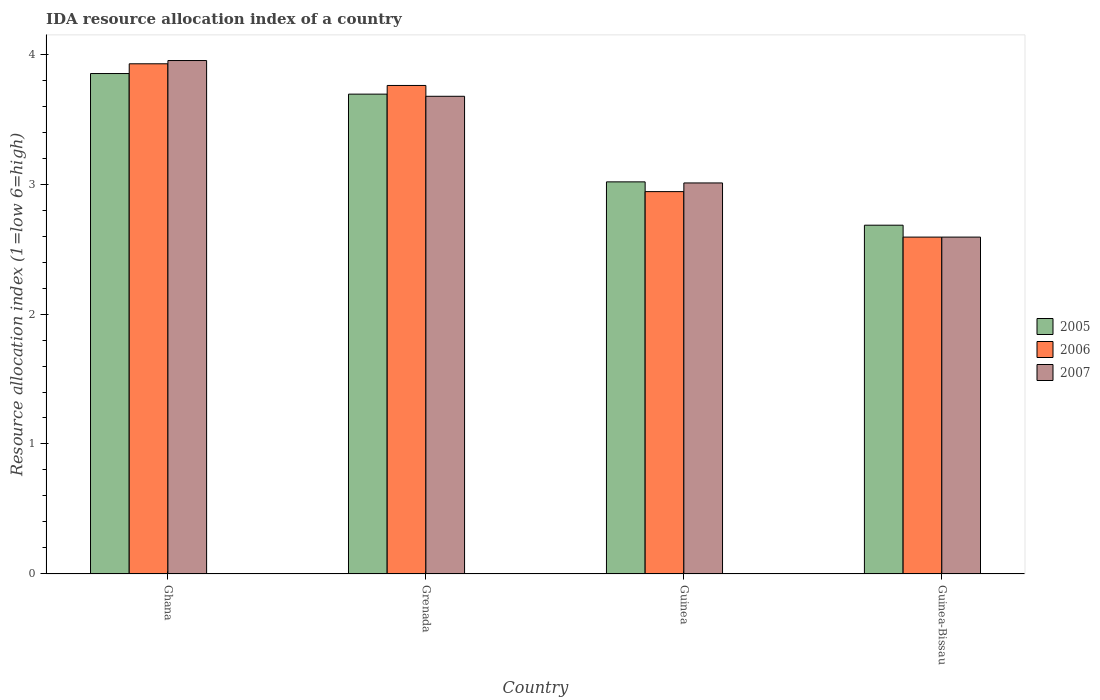How many different coloured bars are there?
Make the answer very short. 3. How many groups of bars are there?
Your response must be concise. 4. How many bars are there on the 2nd tick from the left?
Ensure brevity in your answer.  3. What is the label of the 4th group of bars from the left?
Ensure brevity in your answer.  Guinea-Bissau. In how many cases, is the number of bars for a given country not equal to the number of legend labels?
Your answer should be compact. 0. What is the IDA resource allocation index in 2005 in Guinea?
Your answer should be very brief. 3.02. Across all countries, what is the maximum IDA resource allocation index in 2007?
Your answer should be very brief. 3.95. Across all countries, what is the minimum IDA resource allocation index in 2006?
Offer a terse response. 2.59. In which country was the IDA resource allocation index in 2007 maximum?
Your answer should be compact. Ghana. In which country was the IDA resource allocation index in 2005 minimum?
Give a very brief answer. Guinea-Bissau. What is the total IDA resource allocation index in 2005 in the graph?
Make the answer very short. 13.24. What is the difference between the IDA resource allocation index in 2007 in Ghana and that in Guinea-Bissau?
Your answer should be very brief. 1.36. What is the difference between the IDA resource allocation index in 2005 in Guinea-Bissau and the IDA resource allocation index in 2006 in Guinea?
Ensure brevity in your answer.  -0.26. What is the average IDA resource allocation index in 2006 per country?
Ensure brevity in your answer.  3.3. What is the difference between the IDA resource allocation index of/in 2006 and IDA resource allocation index of/in 2005 in Grenada?
Your response must be concise. 0.07. In how many countries, is the IDA resource allocation index in 2007 greater than 2.2?
Offer a very short reply. 4. What is the ratio of the IDA resource allocation index in 2007 in Ghana to that in Grenada?
Your response must be concise. 1.07. Is the difference between the IDA resource allocation index in 2006 in Guinea and Guinea-Bissau greater than the difference between the IDA resource allocation index in 2005 in Guinea and Guinea-Bissau?
Your response must be concise. Yes. What is the difference between the highest and the second highest IDA resource allocation index in 2005?
Make the answer very short. 0.67. What is the difference between the highest and the lowest IDA resource allocation index in 2007?
Your answer should be compact. 1.36. In how many countries, is the IDA resource allocation index in 2006 greater than the average IDA resource allocation index in 2006 taken over all countries?
Your answer should be very brief. 2. What does the 3rd bar from the left in Grenada represents?
Ensure brevity in your answer.  2007. What does the 3rd bar from the right in Ghana represents?
Your answer should be very brief. 2005. Are all the bars in the graph horizontal?
Your answer should be very brief. No. How many countries are there in the graph?
Offer a terse response. 4. Does the graph contain any zero values?
Your response must be concise. No. Does the graph contain grids?
Provide a succinct answer. No. How many legend labels are there?
Provide a short and direct response. 3. What is the title of the graph?
Your answer should be compact. IDA resource allocation index of a country. Does "1970" appear as one of the legend labels in the graph?
Your response must be concise. No. What is the label or title of the X-axis?
Provide a short and direct response. Country. What is the label or title of the Y-axis?
Provide a short and direct response. Resource allocation index (1=low 6=high). What is the Resource allocation index (1=low 6=high) of 2005 in Ghana?
Make the answer very short. 3.85. What is the Resource allocation index (1=low 6=high) in 2006 in Ghana?
Provide a succinct answer. 3.92. What is the Resource allocation index (1=low 6=high) in 2007 in Ghana?
Keep it short and to the point. 3.95. What is the Resource allocation index (1=low 6=high) in 2005 in Grenada?
Your response must be concise. 3.69. What is the Resource allocation index (1=low 6=high) of 2006 in Grenada?
Make the answer very short. 3.76. What is the Resource allocation index (1=low 6=high) of 2007 in Grenada?
Keep it short and to the point. 3.67. What is the Resource allocation index (1=low 6=high) in 2005 in Guinea?
Keep it short and to the point. 3.02. What is the Resource allocation index (1=low 6=high) of 2006 in Guinea?
Offer a terse response. 2.94. What is the Resource allocation index (1=low 6=high) in 2007 in Guinea?
Offer a terse response. 3.01. What is the Resource allocation index (1=low 6=high) of 2005 in Guinea-Bissau?
Offer a very short reply. 2.68. What is the Resource allocation index (1=low 6=high) in 2006 in Guinea-Bissau?
Offer a terse response. 2.59. What is the Resource allocation index (1=low 6=high) of 2007 in Guinea-Bissau?
Your response must be concise. 2.59. Across all countries, what is the maximum Resource allocation index (1=low 6=high) in 2005?
Keep it short and to the point. 3.85. Across all countries, what is the maximum Resource allocation index (1=low 6=high) of 2006?
Your response must be concise. 3.92. Across all countries, what is the maximum Resource allocation index (1=low 6=high) of 2007?
Your answer should be compact. 3.95. Across all countries, what is the minimum Resource allocation index (1=low 6=high) in 2005?
Provide a succinct answer. 2.68. Across all countries, what is the minimum Resource allocation index (1=low 6=high) of 2006?
Offer a terse response. 2.59. Across all countries, what is the minimum Resource allocation index (1=low 6=high) in 2007?
Your answer should be compact. 2.59. What is the total Resource allocation index (1=low 6=high) of 2005 in the graph?
Make the answer very short. 13.24. What is the total Resource allocation index (1=low 6=high) of 2006 in the graph?
Make the answer very short. 13.22. What is the total Resource allocation index (1=low 6=high) in 2007 in the graph?
Offer a very short reply. 13.22. What is the difference between the Resource allocation index (1=low 6=high) of 2005 in Ghana and that in Grenada?
Provide a succinct answer. 0.16. What is the difference between the Resource allocation index (1=low 6=high) in 2006 in Ghana and that in Grenada?
Provide a succinct answer. 0.17. What is the difference between the Resource allocation index (1=low 6=high) in 2007 in Ghana and that in Grenada?
Your answer should be compact. 0.28. What is the difference between the Resource allocation index (1=low 6=high) in 2005 in Ghana and that in Guinea?
Your answer should be very brief. 0.83. What is the difference between the Resource allocation index (1=low 6=high) in 2006 in Ghana and that in Guinea?
Keep it short and to the point. 0.98. What is the difference between the Resource allocation index (1=low 6=high) of 2007 in Ghana and that in Guinea?
Your answer should be very brief. 0.94. What is the difference between the Resource allocation index (1=low 6=high) in 2007 in Ghana and that in Guinea-Bissau?
Give a very brief answer. 1.36. What is the difference between the Resource allocation index (1=low 6=high) in 2005 in Grenada and that in Guinea?
Your response must be concise. 0.68. What is the difference between the Resource allocation index (1=low 6=high) in 2006 in Grenada and that in Guinea?
Keep it short and to the point. 0.82. What is the difference between the Resource allocation index (1=low 6=high) in 2007 in Grenada and that in Guinea?
Your response must be concise. 0.67. What is the difference between the Resource allocation index (1=low 6=high) in 2005 in Grenada and that in Guinea-Bissau?
Give a very brief answer. 1.01. What is the difference between the Resource allocation index (1=low 6=high) in 2006 in Grenada and that in Guinea-Bissau?
Give a very brief answer. 1.17. What is the difference between the Resource allocation index (1=low 6=high) in 2007 in Guinea and that in Guinea-Bissau?
Make the answer very short. 0.42. What is the difference between the Resource allocation index (1=low 6=high) in 2005 in Ghana and the Resource allocation index (1=low 6=high) in 2006 in Grenada?
Ensure brevity in your answer.  0.09. What is the difference between the Resource allocation index (1=low 6=high) in 2005 in Ghana and the Resource allocation index (1=low 6=high) in 2007 in Grenada?
Provide a succinct answer. 0.17. What is the difference between the Resource allocation index (1=low 6=high) in 2005 in Ghana and the Resource allocation index (1=low 6=high) in 2006 in Guinea?
Offer a terse response. 0.91. What is the difference between the Resource allocation index (1=low 6=high) of 2005 in Ghana and the Resource allocation index (1=low 6=high) of 2007 in Guinea?
Provide a succinct answer. 0.84. What is the difference between the Resource allocation index (1=low 6=high) in 2005 in Ghana and the Resource allocation index (1=low 6=high) in 2006 in Guinea-Bissau?
Provide a short and direct response. 1.26. What is the difference between the Resource allocation index (1=low 6=high) of 2005 in Ghana and the Resource allocation index (1=low 6=high) of 2007 in Guinea-Bissau?
Your response must be concise. 1.26. What is the difference between the Resource allocation index (1=low 6=high) in 2005 in Grenada and the Resource allocation index (1=low 6=high) in 2006 in Guinea?
Provide a succinct answer. 0.75. What is the difference between the Resource allocation index (1=low 6=high) of 2005 in Grenada and the Resource allocation index (1=low 6=high) of 2007 in Guinea?
Offer a terse response. 0.68. What is the difference between the Resource allocation index (1=low 6=high) of 2006 in Grenada and the Resource allocation index (1=low 6=high) of 2007 in Guinea?
Your response must be concise. 0.75. What is the difference between the Resource allocation index (1=low 6=high) of 2005 in Grenada and the Resource allocation index (1=low 6=high) of 2006 in Guinea-Bissau?
Make the answer very short. 1.1. What is the difference between the Resource allocation index (1=low 6=high) in 2005 in Guinea and the Resource allocation index (1=low 6=high) in 2006 in Guinea-Bissau?
Keep it short and to the point. 0.42. What is the difference between the Resource allocation index (1=low 6=high) of 2005 in Guinea and the Resource allocation index (1=low 6=high) of 2007 in Guinea-Bissau?
Your answer should be very brief. 0.42. What is the average Resource allocation index (1=low 6=high) of 2005 per country?
Ensure brevity in your answer.  3.31. What is the average Resource allocation index (1=low 6=high) of 2006 per country?
Offer a terse response. 3.3. What is the average Resource allocation index (1=low 6=high) of 2007 per country?
Ensure brevity in your answer.  3.31. What is the difference between the Resource allocation index (1=low 6=high) of 2005 and Resource allocation index (1=low 6=high) of 2006 in Ghana?
Your answer should be compact. -0.07. What is the difference between the Resource allocation index (1=low 6=high) in 2006 and Resource allocation index (1=low 6=high) in 2007 in Ghana?
Offer a terse response. -0.03. What is the difference between the Resource allocation index (1=low 6=high) in 2005 and Resource allocation index (1=low 6=high) in 2006 in Grenada?
Offer a terse response. -0.07. What is the difference between the Resource allocation index (1=low 6=high) of 2005 and Resource allocation index (1=low 6=high) of 2007 in Grenada?
Offer a very short reply. 0.02. What is the difference between the Resource allocation index (1=low 6=high) in 2006 and Resource allocation index (1=low 6=high) in 2007 in Grenada?
Keep it short and to the point. 0.08. What is the difference between the Resource allocation index (1=low 6=high) in 2005 and Resource allocation index (1=low 6=high) in 2006 in Guinea?
Provide a short and direct response. 0.07. What is the difference between the Resource allocation index (1=low 6=high) of 2005 and Resource allocation index (1=low 6=high) of 2007 in Guinea?
Offer a terse response. 0.01. What is the difference between the Resource allocation index (1=low 6=high) in 2006 and Resource allocation index (1=low 6=high) in 2007 in Guinea?
Provide a succinct answer. -0.07. What is the difference between the Resource allocation index (1=low 6=high) of 2005 and Resource allocation index (1=low 6=high) of 2006 in Guinea-Bissau?
Your response must be concise. 0.09. What is the difference between the Resource allocation index (1=low 6=high) in 2005 and Resource allocation index (1=low 6=high) in 2007 in Guinea-Bissau?
Keep it short and to the point. 0.09. What is the difference between the Resource allocation index (1=low 6=high) in 2006 and Resource allocation index (1=low 6=high) in 2007 in Guinea-Bissau?
Provide a short and direct response. 0. What is the ratio of the Resource allocation index (1=low 6=high) of 2005 in Ghana to that in Grenada?
Make the answer very short. 1.04. What is the ratio of the Resource allocation index (1=low 6=high) of 2006 in Ghana to that in Grenada?
Your answer should be compact. 1.04. What is the ratio of the Resource allocation index (1=low 6=high) in 2007 in Ghana to that in Grenada?
Provide a succinct answer. 1.07. What is the ratio of the Resource allocation index (1=low 6=high) in 2005 in Ghana to that in Guinea?
Your answer should be very brief. 1.28. What is the ratio of the Resource allocation index (1=low 6=high) of 2006 in Ghana to that in Guinea?
Make the answer very short. 1.33. What is the ratio of the Resource allocation index (1=low 6=high) of 2007 in Ghana to that in Guinea?
Give a very brief answer. 1.31. What is the ratio of the Resource allocation index (1=low 6=high) in 2005 in Ghana to that in Guinea-Bissau?
Offer a very short reply. 1.43. What is the ratio of the Resource allocation index (1=low 6=high) in 2006 in Ghana to that in Guinea-Bissau?
Ensure brevity in your answer.  1.51. What is the ratio of the Resource allocation index (1=low 6=high) of 2007 in Ghana to that in Guinea-Bissau?
Your answer should be compact. 1.52. What is the ratio of the Resource allocation index (1=low 6=high) in 2005 in Grenada to that in Guinea?
Your answer should be compact. 1.22. What is the ratio of the Resource allocation index (1=low 6=high) in 2006 in Grenada to that in Guinea?
Give a very brief answer. 1.28. What is the ratio of the Resource allocation index (1=low 6=high) of 2007 in Grenada to that in Guinea?
Keep it short and to the point. 1.22. What is the ratio of the Resource allocation index (1=low 6=high) in 2005 in Grenada to that in Guinea-Bissau?
Offer a terse response. 1.38. What is the ratio of the Resource allocation index (1=low 6=high) in 2006 in Grenada to that in Guinea-Bissau?
Make the answer very short. 1.45. What is the ratio of the Resource allocation index (1=low 6=high) of 2007 in Grenada to that in Guinea-Bissau?
Keep it short and to the point. 1.42. What is the ratio of the Resource allocation index (1=low 6=high) in 2005 in Guinea to that in Guinea-Bissau?
Give a very brief answer. 1.12. What is the ratio of the Resource allocation index (1=low 6=high) of 2006 in Guinea to that in Guinea-Bissau?
Your response must be concise. 1.14. What is the ratio of the Resource allocation index (1=low 6=high) in 2007 in Guinea to that in Guinea-Bissau?
Keep it short and to the point. 1.16. What is the difference between the highest and the second highest Resource allocation index (1=low 6=high) in 2005?
Offer a terse response. 0.16. What is the difference between the highest and the second highest Resource allocation index (1=low 6=high) in 2007?
Your response must be concise. 0.28. What is the difference between the highest and the lowest Resource allocation index (1=low 6=high) in 2005?
Your answer should be compact. 1.17. What is the difference between the highest and the lowest Resource allocation index (1=low 6=high) in 2006?
Provide a short and direct response. 1.33. What is the difference between the highest and the lowest Resource allocation index (1=low 6=high) of 2007?
Your answer should be very brief. 1.36. 